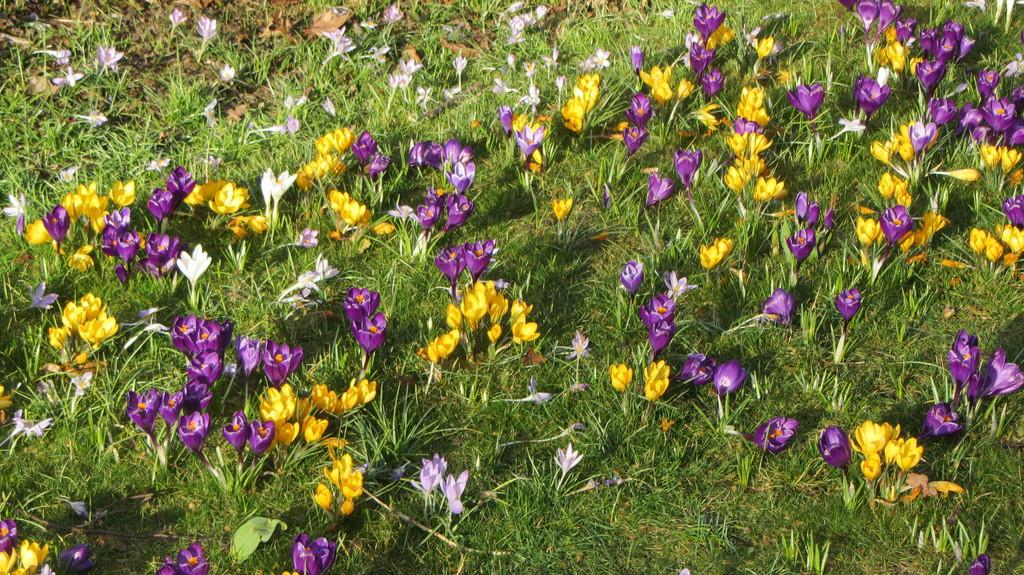What type of plants can be seen in the image? There are flower plants in the image. What colors do the flowers have? The flowers have various colors, including purple and yellow. How many students are being taught by the flowers in the image? There is no indication of teaching or students in the image; it features flower plants with various colors. What type of feet can be seen on the flowers in the image? Flowers do not have feet, as they are plants. 